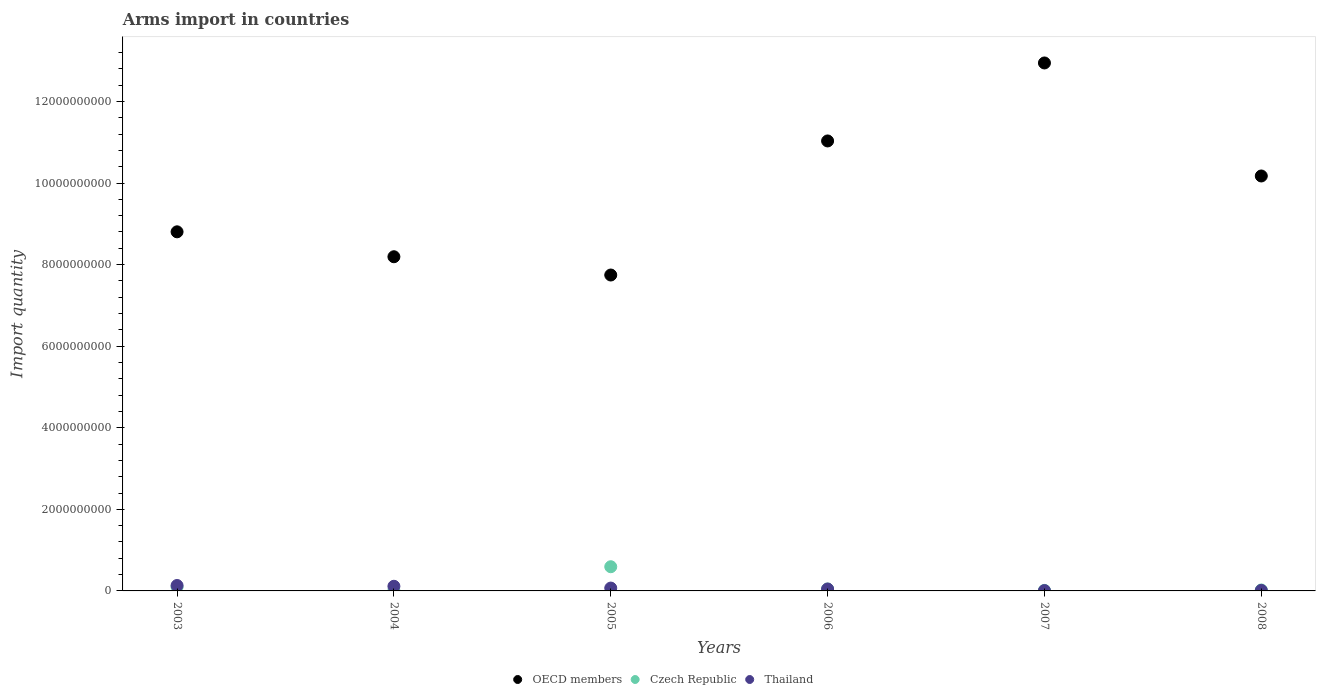How many different coloured dotlines are there?
Provide a short and direct response. 3. Is the number of dotlines equal to the number of legend labels?
Provide a short and direct response. Yes. What is the total arms import in Thailand in 2003?
Your answer should be compact. 1.33e+08. Across all years, what is the maximum total arms import in OECD members?
Keep it short and to the point. 1.29e+1. Across all years, what is the minimum total arms import in Thailand?
Give a very brief answer. 8.00e+06. In which year was the total arms import in Thailand minimum?
Provide a succinct answer. 2007. What is the total total arms import in Thailand in the graph?
Keep it short and to the point. 3.85e+08. What is the difference between the total arms import in Czech Republic in 2003 and that in 2004?
Ensure brevity in your answer.  9.00e+07. What is the difference between the total arms import in OECD members in 2006 and the total arms import in Czech Republic in 2005?
Offer a very short reply. 1.04e+1. What is the average total arms import in OECD members per year?
Provide a succinct answer. 9.82e+09. In the year 2006, what is the difference between the total arms import in Thailand and total arms import in OECD members?
Provide a succinct answer. -1.10e+1. What is the ratio of the total arms import in Czech Republic in 2004 to that in 2006?
Make the answer very short. 0.15. Is the total arms import in Czech Republic in 2007 less than that in 2008?
Your answer should be compact. Yes. Is the difference between the total arms import in Thailand in 2006 and 2008 greater than the difference between the total arms import in OECD members in 2006 and 2008?
Offer a terse response. No. What is the difference between the highest and the second highest total arms import in Czech Republic?
Offer a terse response. 4.96e+08. What is the difference between the highest and the lowest total arms import in Czech Republic?
Keep it short and to the point. 5.86e+08. Is the sum of the total arms import in Czech Republic in 2003 and 2006 greater than the maximum total arms import in OECD members across all years?
Offer a terse response. No. Is it the case that in every year, the sum of the total arms import in Thailand and total arms import in OECD members  is greater than the total arms import in Czech Republic?
Offer a terse response. Yes. Is the total arms import in OECD members strictly greater than the total arms import in Czech Republic over the years?
Ensure brevity in your answer.  Yes. How many years are there in the graph?
Provide a short and direct response. 6. What is the difference between two consecutive major ticks on the Y-axis?
Your response must be concise. 2.00e+09. Are the values on the major ticks of Y-axis written in scientific E-notation?
Offer a very short reply. No. Does the graph contain any zero values?
Keep it short and to the point. No. Where does the legend appear in the graph?
Make the answer very short. Bottom center. What is the title of the graph?
Provide a short and direct response. Arms import in countries. Does "Chile" appear as one of the legend labels in the graph?
Ensure brevity in your answer.  No. What is the label or title of the X-axis?
Offer a terse response. Years. What is the label or title of the Y-axis?
Provide a short and direct response. Import quantity. What is the Import quantity of OECD members in 2003?
Ensure brevity in your answer.  8.80e+09. What is the Import quantity of Czech Republic in 2003?
Your answer should be compact. 9.70e+07. What is the Import quantity of Thailand in 2003?
Keep it short and to the point. 1.33e+08. What is the Import quantity of OECD members in 2004?
Your response must be concise. 8.19e+09. What is the Import quantity in Czech Republic in 2004?
Make the answer very short. 7.00e+06. What is the Import quantity of Thailand in 2004?
Make the answer very short. 1.14e+08. What is the Import quantity in OECD members in 2005?
Ensure brevity in your answer.  7.74e+09. What is the Import quantity in Czech Republic in 2005?
Your answer should be compact. 5.93e+08. What is the Import quantity in Thailand in 2005?
Your answer should be very brief. 7.00e+07. What is the Import quantity of OECD members in 2006?
Keep it short and to the point. 1.10e+1. What is the Import quantity of Czech Republic in 2006?
Your answer should be very brief. 4.70e+07. What is the Import quantity in Thailand in 2006?
Provide a short and direct response. 4.70e+07. What is the Import quantity in OECD members in 2007?
Provide a succinct answer. 1.29e+1. What is the Import quantity in Czech Republic in 2007?
Ensure brevity in your answer.  1.30e+07. What is the Import quantity of OECD members in 2008?
Offer a terse response. 1.02e+1. What is the Import quantity of Czech Republic in 2008?
Your answer should be compact. 2.30e+07. What is the Import quantity of Thailand in 2008?
Give a very brief answer. 1.30e+07. Across all years, what is the maximum Import quantity in OECD members?
Your answer should be compact. 1.29e+1. Across all years, what is the maximum Import quantity in Czech Republic?
Keep it short and to the point. 5.93e+08. Across all years, what is the maximum Import quantity in Thailand?
Your answer should be compact. 1.33e+08. Across all years, what is the minimum Import quantity of OECD members?
Offer a very short reply. 7.74e+09. Across all years, what is the minimum Import quantity in Czech Republic?
Provide a short and direct response. 7.00e+06. Across all years, what is the minimum Import quantity in Thailand?
Provide a short and direct response. 8.00e+06. What is the total Import quantity in OECD members in the graph?
Make the answer very short. 5.89e+1. What is the total Import quantity of Czech Republic in the graph?
Your answer should be compact. 7.80e+08. What is the total Import quantity of Thailand in the graph?
Offer a very short reply. 3.85e+08. What is the difference between the Import quantity in OECD members in 2003 and that in 2004?
Keep it short and to the point. 6.11e+08. What is the difference between the Import quantity of Czech Republic in 2003 and that in 2004?
Offer a very short reply. 9.00e+07. What is the difference between the Import quantity of Thailand in 2003 and that in 2004?
Provide a short and direct response. 1.90e+07. What is the difference between the Import quantity in OECD members in 2003 and that in 2005?
Your response must be concise. 1.06e+09. What is the difference between the Import quantity of Czech Republic in 2003 and that in 2005?
Keep it short and to the point. -4.96e+08. What is the difference between the Import quantity in Thailand in 2003 and that in 2005?
Provide a short and direct response. 6.30e+07. What is the difference between the Import quantity in OECD members in 2003 and that in 2006?
Make the answer very short. -2.23e+09. What is the difference between the Import quantity of Thailand in 2003 and that in 2006?
Your answer should be compact. 8.60e+07. What is the difference between the Import quantity in OECD members in 2003 and that in 2007?
Your answer should be compact. -4.14e+09. What is the difference between the Import quantity in Czech Republic in 2003 and that in 2007?
Make the answer very short. 8.40e+07. What is the difference between the Import quantity in Thailand in 2003 and that in 2007?
Ensure brevity in your answer.  1.25e+08. What is the difference between the Import quantity of OECD members in 2003 and that in 2008?
Provide a succinct answer. -1.37e+09. What is the difference between the Import quantity in Czech Republic in 2003 and that in 2008?
Your answer should be compact. 7.40e+07. What is the difference between the Import quantity of Thailand in 2003 and that in 2008?
Keep it short and to the point. 1.20e+08. What is the difference between the Import quantity of OECD members in 2004 and that in 2005?
Provide a short and direct response. 4.48e+08. What is the difference between the Import quantity in Czech Republic in 2004 and that in 2005?
Give a very brief answer. -5.86e+08. What is the difference between the Import quantity in Thailand in 2004 and that in 2005?
Your answer should be compact. 4.40e+07. What is the difference between the Import quantity of OECD members in 2004 and that in 2006?
Provide a succinct answer. -2.84e+09. What is the difference between the Import quantity of Czech Republic in 2004 and that in 2006?
Your response must be concise. -4.00e+07. What is the difference between the Import quantity in Thailand in 2004 and that in 2006?
Your answer should be very brief. 6.70e+07. What is the difference between the Import quantity in OECD members in 2004 and that in 2007?
Provide a succinct answer. -4.75e+09. What is the difference between the Import quantity of Czech Republic in 2004 and that in 2007?
Offer a terse response. -6.00e+06. What is the difference between the Import quantity in Thailand in 2004 and that in 2007?
Keep it short and to the point. 1.06e+08. What is the difference between the Import quantity in OECD members in 2004 and that in 2008?
Provide a succinct answer. -1.98e+09. What is the difference between the Import quantity of Czech Republic in 2004 and that in 2008?
Provide a short and direct response. -1.60e+07. What is the difference between the Import quantity in Thailand in 2004 and that in 2008?
Your answer should be very brief. 1.01e+08. What is the difference between the Import quantity of OECD members in 2005 and that in 2006?
Keep it short and to the point. -3.29e+09. What is the difference between the Import quantity in Czech Republic in 2005 and that in 2006?
Provide a short and direct response. 5.46e+08. What is the difference between the Import quantity in Thailand in 2005 and that in 2006?
Keep it short and to the point. 2.30e+07. What is the difference between the Import quantity of OECD members in 2005 and that in 2007?
Make the answer very short. -5.20e+09. What is the difference between the Import quantity in Czech Republic in 2005 and that in 2007?
Offer a very short reply. 5.80e+08. What is the difference between the Import quantity of Thailand in 2005 and that in 2007?
Offer a very short reply. 6.20e+07. What is the difference between the Import quantity in OECD members in 2005 and that in 2008?
Offer a very short reply. -2.43e+09. What is the difference between the Import quantity in Czech Republic in 2005 and that in 2008?
Your response must be concise. 5.70e+08. What is the difference between the Import quantity in Thailand in 2005 and that in 2008?
Your answer should be compact. 5.70e+07. What is the difference between the Import quantity in OECD members in 2006 and that in 2007?
Offer a terse response. -1.91e+09. What is the difference between the Import quantity in Czech Republic in 2006 and that in 2007?
Give a very brief answer. 3.40e+07. What is the difference between the Import quantity in Thailand in 2006 and that in 2007?
Your response must be concise. 3.90e+07. What is the difference between the Import quantity in OECD members in 2006 and that in 2008?
Your answer should be very brief. 8.59e+08. What is the difference between the Import quantity of Czech Republic in 2006 and that in 2008?
Your response must be concise. 2.40e+07. What is the difference between the Import quantity in Thailand in 2006 and that in 2008?
Your answer should be compact. 3.40e+07. What is the difference between the Import quantity in OECD members in 2007 and that in 2008?
Give a very brief answer. 2.77e+09. What is the difference between the Import quantity in Czech Republic in 2007 and that in 2008?
Provide a short and direct response. -1.00e+07. What is the difference between the Import quantity in Thailand in 2007 and that in 2008?
Offer a terse response. -5.00e+06. What is the difference between the Import quantity in OECD members in 2003 and the Import quantity in Czech Republic in 2004?
Provide a short and direct response. 8.80e+09. What is the difference between the Import quantity of OECD members in 2003 and the Import quantity of Thailand in 2004?
Ensure brevity in your answer.  8.69e+09. What is the difference between the Import quantity of Czech Republic in 2003 and the Import quantity of Thailand in 2004?
Your answer should be very brief. -1.70e+07. What is the difference between the Import quantity of OECD members in 2003 and the Import quantity of Czech Republic in 2005?
Your response must be concise. 8.21e+09. What is the difference between the Import quantity in OECD members in 2003 and the Import quantity in Thailand in 2005?
Offer a terse response. 8.73e+09. What is the difference between the Import quantity of Czech Republic in 2003 and the Import quantity of Thailand in 2005?
Keep it short and to the point. 2.70e+07. What is the difference between the Import quantity in OECD members in 2003 and the Import quantity in Czech Republic in 2006?
Keep it short and to the point. 8.76e+09. What is the difference between the Import quantity of OECD members in 2003 and the Import quantity of Thailand in 2006?
Give a very brief answer. 8.76e+09. What is the difference between the Import quantity of Czech Republic in 2003 and the Import quantity of Thailand in 2006?
Your response must be concise. 5.00e+07. What is the difference between the Import quantity of OECD members in 2003 and the Import quantity of Czech Republic in 2007?
Your response must be concise. 8.79e+09. What is the difference between the Import quantity in OECD members in 2003 and the Import quantity in Thailand in 2007?
Your response must be concise. 8.80e+09. What is the difference between the Import quantity of Czech Republic in 2003 and the Import quantity of Thailand in 2007?
Make the answer very short. 8.90e+07. What is the difference between the Import quantity in OECD members in 2003 and the Import quantity in Czech Republic in 2008?
Keep it short and to the point. 8.78e+09. What is the difference between the Import quantity in OECD members in 2003 and the Import quantity in Thailand in 2008?
Ensure brevity in your answer.  8.79e+09. What is the difference between the Import quantity of Czech Republic in 2003 and the Import quantity of Thailand in 2008?
Provide a succinct answer. 8.40e+07. What is the difference between the Import quantity in OECD members in 2004 and the Import quantity in Czech Republic in 2005?
Your response must be concise. 7.60e+09. What is the difference between the Import quantity in OECD members in 2004 and the Import quantity in Thailand in 2005?
Offer a very short reply. 8.12e+09. What is the difference between the Import quantity in Czech Republic in 2004 and the Import quantity in Thailand in 2005?
Offer a terse response. -6.30e+07. What is the difference between the Import quantity of OECD members in 2004 and the Import quantity of Czech Republic in 2006?
Offer a terse response. 8.15e+09. What is the difference between the Import quantity in OECD members in 2004 and the Import quantity in Thailand in 2006?
Ensure brevity in your answer.  8.15e+09. What is the difference between the Import quantity of Czech Republic in 2004 and the Import quantity of Thailand in 2006?
Keep it short and to the point. -4.00e+07. What is the difference between the Import quantity in OECD members in 2004 and the Import quantity in Czech Republic in 2007?
Ensure brevity in your answer.  8.18e+09. What is the difference between the Import quantity in OECD members in 2004 and the Import quantity in Thailand in 2007?
Offer a terse response. 8.18e+09. What is the difference between the Import quantity of Czech Republic in 2004 and the Import quantity of Thailand in 2007?
Make the answer very short. -1.00e+06. What is the difference between the Import quantity in OECD members in 2004 and the Import quantity in Czech Republic in 2008?
Offer a terse response. 8.17e+09. What is the difference between the Import quantity in OECD members in 2004 and the Import quantity in Thailand in 2008?
Ensure brevity in your answer.  8.18e+09. What is the difference between the Import quantity of Czech Republic in 2004 and the Import quantity of Thailand in 2008?
Ensure brevity in your answer.  -6.00e+06. What is the difference between the Import quantity of OECD members in 2005 and the Import quantity of Czech Republic in 2006?
Provide a succinct answer. 7.70e+09. What is the difference between the Import quantity of OECD members in 2005 and the Import quantity of Thailand in 2006?
Your answer should be very brief. 7.70e+09. What is the difference between the Import quantity of Czech Republic in 2005 and the Import quantity of Thailand in 2006?
Offer a very short reply. 5.46e+08. What is the difference between the Import quantity of OECD members in 2005 and the Import quantity of Czech Republic in 2007?
Your answer should be compact. 7.73e+09. What is the difference between the Import quantity of OECD members in 2005 and the Import quantity of Thailand in 2007?
Ensure brevity in your answer.  7.74e+09. What is the difference between the Import quantity of Czech Republic in 2005 and the Import quantity of Thailand in 2007?
Provide a short and direct response. 5.85e+08. What is the difference between the Import quantity of OECD members in 2005 and the Import quantity of Czech Republic in 2008?
Offer a very short reply. 7.72e+09. What is the difference between the Import quantity of OECD members in 2005 and the Import quantity of Thailand in 2008?
Keep it short and to the point. 7.73e+09. What is the difference between the Import quantity in Czech Republic in 2005 and the Import quantity in Thailand in 2008?
Keep it short and to the point. 5.80e+08. What is the difference between the Import quantity of OECD members in 2006 and the Import quantity of Czech Republic in 2007?
Your response must be concise. 1.10e+1. What is the difference between the Import quantity in OECD members in 2006 and the Import quantity in Thailand in 2007?
Your answer should be very brief. 1.10e+1. What is the difference between the Import quantity in Czech Republic in 2006 and the Import quantity in Thailand in 2007?
Your answer should be very brief. 3.90e+07. What is the difference between the Import quantity in OECD members in 2006 and the Import quantity in Czech Republic in 2008?
Provide a succinct answer. 1.10e+1. What is the difference between the Import quantity of OECD members in 2006 and the Import quantity of Thailand in 2008?
Provide a short and direct response. 1.10e+1. What is the difference between the Import quantity in Czech Republic in 2006 and the Import quantity in Thailand in 2008?
Ensure brevity in your answer.  3.40e+07. What is the difference between the Import quantity in OECD members in 2007 and the Import quantity in Czech Republic in 2008?
Provide a succinct answer. 1.29e+1. What is the difference between the Import quantity of OECD members in 2007 and the Import quantity of Thailand in 2008?
Give a very brief answer. 1.29e+1. What is the average Import quantity in OECD members per year?
Provide a succinct answer. 9.82e+09. What is the average Import quantity in Czech Republic per year?
Your answer should be compact. 1.30e+08. What is the average Import quantity of Thailand per year?
Your response must be concise. 6.42e+07. In the year 2003, what is the difference between the Import quantity of OECD members and Import quantity of Czech Republic?
Make the answer very short. 8.71e+09. In the year 2003, what is the difference between the Import quantity of OECD members and Import quantity of Thailand?
Provide a succinct answer. 8.67e+09. In the year 2003, what is the difference between the Import quantity of Czech Republic and Import quantity of Thailand?
Your response must be concise. -3.60e+07. In the year 2004, what is the difference between the Import quantity in OECD members and Import quantity in Czech Republic?
Ensure brevity in your answer.  8.19e+09. In the year 2004, what is the difference between the Import quantity in OECD members and Import quantity in Thailand?
Your response must be concise. 8.08e+09. In the year 2004, what is the difference between the Import quantity in Czech Republic and Import quantity in Thailand?
Your response must be concise. -1.07e+08. In the year 2005, what is the difference between the Import quantity of OECD members and Import quantity of Czech Republic?
Provide a short and direct response. 7.15e+09. In the year 2005, what is the difference between the Import quantity of OECD members and Import quantity of Thailand?
Your response must be concise. 7.68e+09. In the year 2005, what is the difference between the Import quantity in Czech Republic and Import quantity in Thailand?
Your answer should be compact. 5.23e+08. In the year 2006, what is the difference between the Import quantity in OECD members and Import quantity in Czech Republic?
Offer a terse response. 1.10e+1. In the year 2006, what is the difference between the Import quantity of OECD members and Import quantity of Thailand?
Give a very brief answer. 1.10e+1. In the year 2007, what is the difference between the Import quantity in OECD members and Import quantity in Czech Republic?
Ensure brevity in your answer.  1.29e+1. In the year 2007, what is the difference between the Import quantity of OECD members and Import quantity of Thailand?
Offer a very short reply. 1.29e+1. In the year 2008, what is the difference between the Import quantity of OECD members and Import quantity of Czech Republic?
Give a very brief answer. 1.02e+1. In the year 2008, what is the difference between the Import quantity in OECD members and Import quantity in Thailand?
Keep it short and to the point. 1.02e+1. In the year 2008, what is the difference between the Import quantity of Czech Republic and Import quantity of Thailand?
Make the answer very short. 1.00e+07. What is the ratio of the Import quantity of OECD members in 2003 to that in 2004?
Make the answer very short. 1.07. What is the ratio of the Import quantity of Czech Republic in 2003 to that in 2004?
Keep it short and to the point. 13.86. What is the ratio of the Import quantity of OECD members in 2003 to that in 2005?
Your response must be concise. 1.14. What is the ratio of the Import quantity in Czech Republic in 2003 to that in 2005?
Ensure brevity in your answer.  0.16. What is the ratio of the Import quantity in Thailand in 2003 to that in 2005?
Your response must be concise. 1.9. What is the ratio of the Import quantity in OECD members in 2003 to that in 2006?
Offer a terse response. 0.8. What is the ratio of the Import quantity of Czech Republic in 2003 to that in 2006?
Offer a very short reply. 2.06. What is the ratio of the Import quantity of Thailand in 2003 to that in 2006?
Your response must be concise. 2.83. What is the ratio of the Import quantity of OECD members in 2003 to that in 2007?
Keep it short and to the point. 0.68. What is the ratio of the Import quantity of Czech Republic in 2003 to that in 2007?
Offer a terse response. 7.46. What is the ratio of the Import quantity in Thailand in 2003 to that in 2007?
Provide a succinct answer. 16.62. What is the ratio of the Import quantity of OECD members in 2003 to that in 2008?
Your answer should be very brief. 0.87. What is the ratio of the Import quantity of Czech Republic in 2003 to that in 2008?
Your response must be concise. 4.22. What is the ratio of the Import quantity in Thailand in 2003 to that in 2008?
Provide a succinct answer. 10.23. What is the ratio of the Import quantity in OECD members in 2004 to that in 2005?
Offer a very short reply. 1.06. What is the ratio of the Import quantity of Czech Republic in 2004 to that in 2005?
Offer a very short reply. 0.01. What is the ratio of the Import quantity of Thailand in 2004 to that in 2005?
Give a very brief answer. 1.63. What is the ratio of the Import quantity in OECD members in 2004 to that in 2006?
Your answer should be compact. 0.74. What is the ratio of the Import quantity in Czech Republic in 2004 to that in 2006?
Give a very brief answer. 0.15. What is the ratio of the Import quantity of Thailand in 2004 to that in 2006?
Provide a succinct answer. 2.43. What is the ratio of the Import quantity in OECD members in 2004 to that in 2007?
Ensure brevity in your answer.  0.63. What is the ratio of the Import quantity in Czech Republic in 2004 to that in 2007?
Your answer should be very brief. 0.54. What is the ratio of the Import quantity of Thailand in 2004 to that in 2007?
Provide a short and direct response. 14.25. What is the ratio of the Import quantity of OECD members in 2004 to that in 2008?
Your response must be concise. 0.81. What is the ratio of the Import quantity of Czech Republic in 2004 to that in 2008?
Your answer should be compact. 0.3. What is the ratio of the Import quantity of Thailand in 2004 to that in 2008?
Offer a very short reply. 8.77. What is the ratio of the Import quantity of OECD members in 2005 to that in 2006?
Your answer should be compact. 0.7. What is the ratio of the Import quantity in Czech Republic in 2005 to that in 2006?
Your response must be concise. 12.62. What is the ratio of the Import quantity in Thailand in 2005 to that in 2006?
Provide a succinct answer. 1.49. What is the ratio of the Import quantity in OECD members in 2005 to that in 2007?
Offer a terse response. 0.6. What is the ratio of the Import quantity of Czech Republic in 2005 to that in 2007?
Give a very brief answer. 45.62. What is the ratio of the Import quantity of Thailand in 2005 to that in 2007?
Make the answer very short. 8.75. What is the ratio of the Import quantity in OECD members in 2005 to that in 2008?
Give a very brief answer. 0.76. What is the ratio of the Import quantity in Czech Republic in 2005 to that in 2008?
Provide a short and direct response. 25.78. What is the ratio of the Import quantity in Thailand in 2005 to that in 2008?
Offer a terse response. 5.38. What is the ratio of the Import quantity of OECD members in 2006 to that in 2007?
Ensure brevity in your answer.  0.85. What is the ratio of the Import quantity in Czech Republic in 2006 to that in 2007?
Your answer should be very brief. 3.62. What is the ratio of the Import quantity of Thailand in 2006 to that in 2007?
Provide a short and direct response. 5.88. What is the ratio of the Import quantity in OECD members in 2006 to that in 2008?
Give a very brief answer. 1.08. What is the ratio of the Import quantity in Czech Republic in 2006 to that in 2008?
Offer a terse response. 2.04. What is the ratio of the Import quantity in Thailand in 2006 to that in 2008?
Provide a short and direct response. 3.62. What is the ratio of the Import quantity of OECD members in 2007 to that in 2008?
Make the answer very short. 1.27. What is the ratio of the Import quantity in Czech Republic in 2007 to that in 2008?
Your response must be concise. 0.57. What is the ratio of the Import quantity in Thailand in 2007 to that in 2008?
Your answer should be compact. 0.62. What is the difference between the highest and the second highest Import quantity in OECD members?
Offer a terse response. 1.91e+09. What is the difference between the highest and the second highest Import quantity of Czech Republic?
Offer a very short reply. 4.96e+08. What is the difference between the highest and the second highest Import quantity of Thailand?
Your answer should be very brief. 1.90e+07. What is the difference between the highest and the lowest Import quantity in OECD members?
Your response must be concise. 5.20e+09. What is the difference between the highest and the lowest Import quantity in Czech Republic?
Offer a terse response. 5.86e+08. What is the difference between the highest and the lowest Import quantity of Thailand?
Provide a succinct answer. 1.25e+08. 